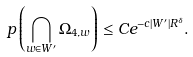<formula> <loc_0><loc_0><loc_500><loc_500>\ p \left ( \bigcap _ { w \in W ^ { \prime } } \Omega _ { 4 , w } \right ) \leq C e ^ { - c | W ^ { \prime } | R ^ { \delta } } .</formula> 